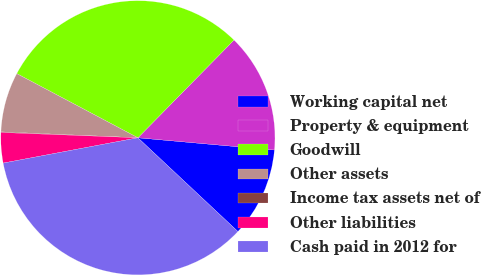<chart> <loc_0><loc_0><loc_500><loc_500><pie_chart><fcel>Working capital net<fcel>Property & equipment<fcel>Goodwill<fcel>Other assets<fcel>Income tax assets net of<fcel>Other liabilities<fcel>Cash paid in 2012 for<nl><fcel>10.56%<fcel>14.06%<fcel>29.61%<fcel>7.07%<fcel>0.07%<fcel>3.57%<fcel>35.06%<nl></chart> 